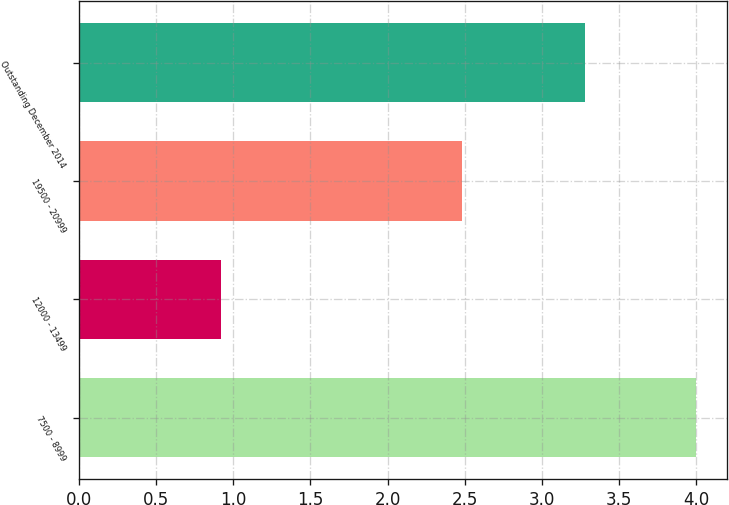Convert chart. <chart><loc_0><loc_0><loc_500><loc_500><bar_chart><fcel>7500 - 8999<fcel>12000 - 13499<fcel>19500 - 20999<fcel>Outstanding December 2014<nl><fcel>4<fcel>0.92<fcel>2.48<fcel>3.28<nl></chart> 